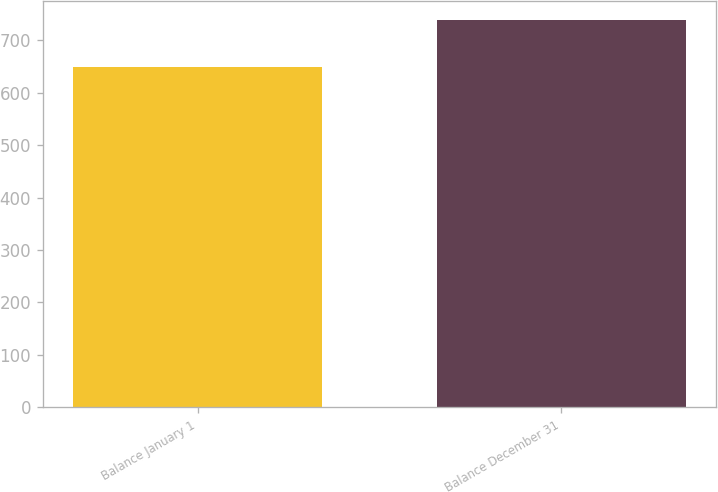Convert chart to OTSL. <chart><loc_0><loc_0><loc_500><loc_500><bar_chart><fcel>Balance January 1<fcel>Balance December 31<nl><fcel>650<fcel>739<nl></chart> 